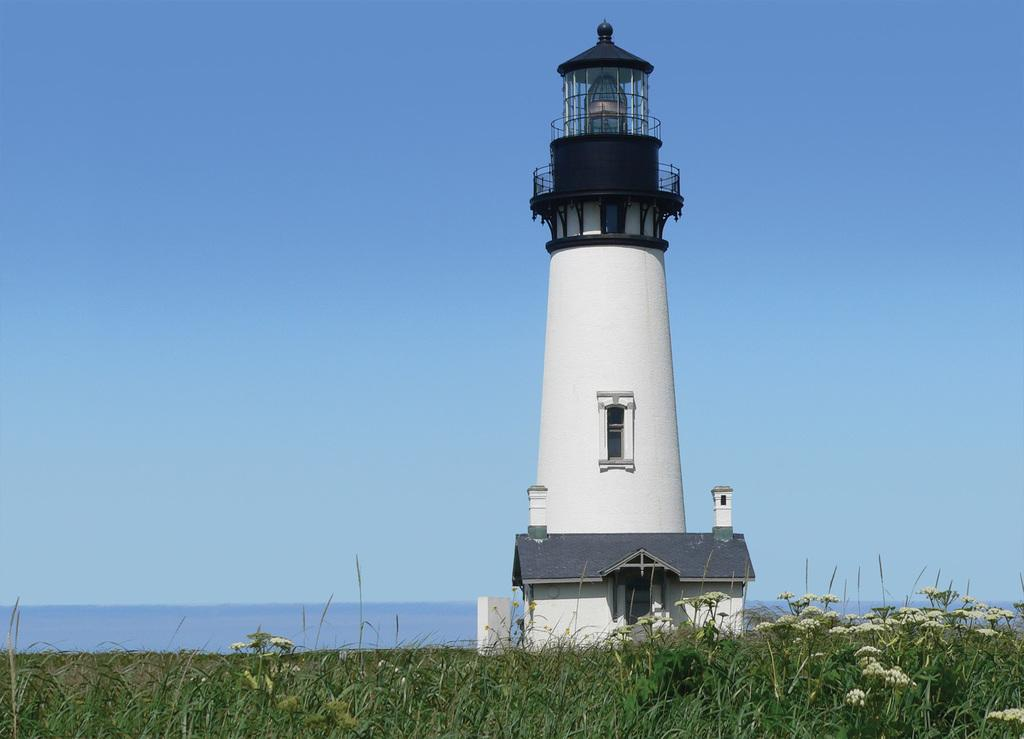What structure is the main focus of the image? There is a light tower in the image. What type of landscape can be seen at the bottom of the image? Farmland is visible at the bottom of the image. What type of vegetation is present in the image? There are plants and flowers in the image. What natural features can be seen in the background of the image? The ocean is visible in the background of the image. What is visible at the top of the image? The sky is visible at the top of the image. What is the maid discussing with the flowers in the image? There is no maid present in the image, and therefore no discussion with the flowers can be observed. 